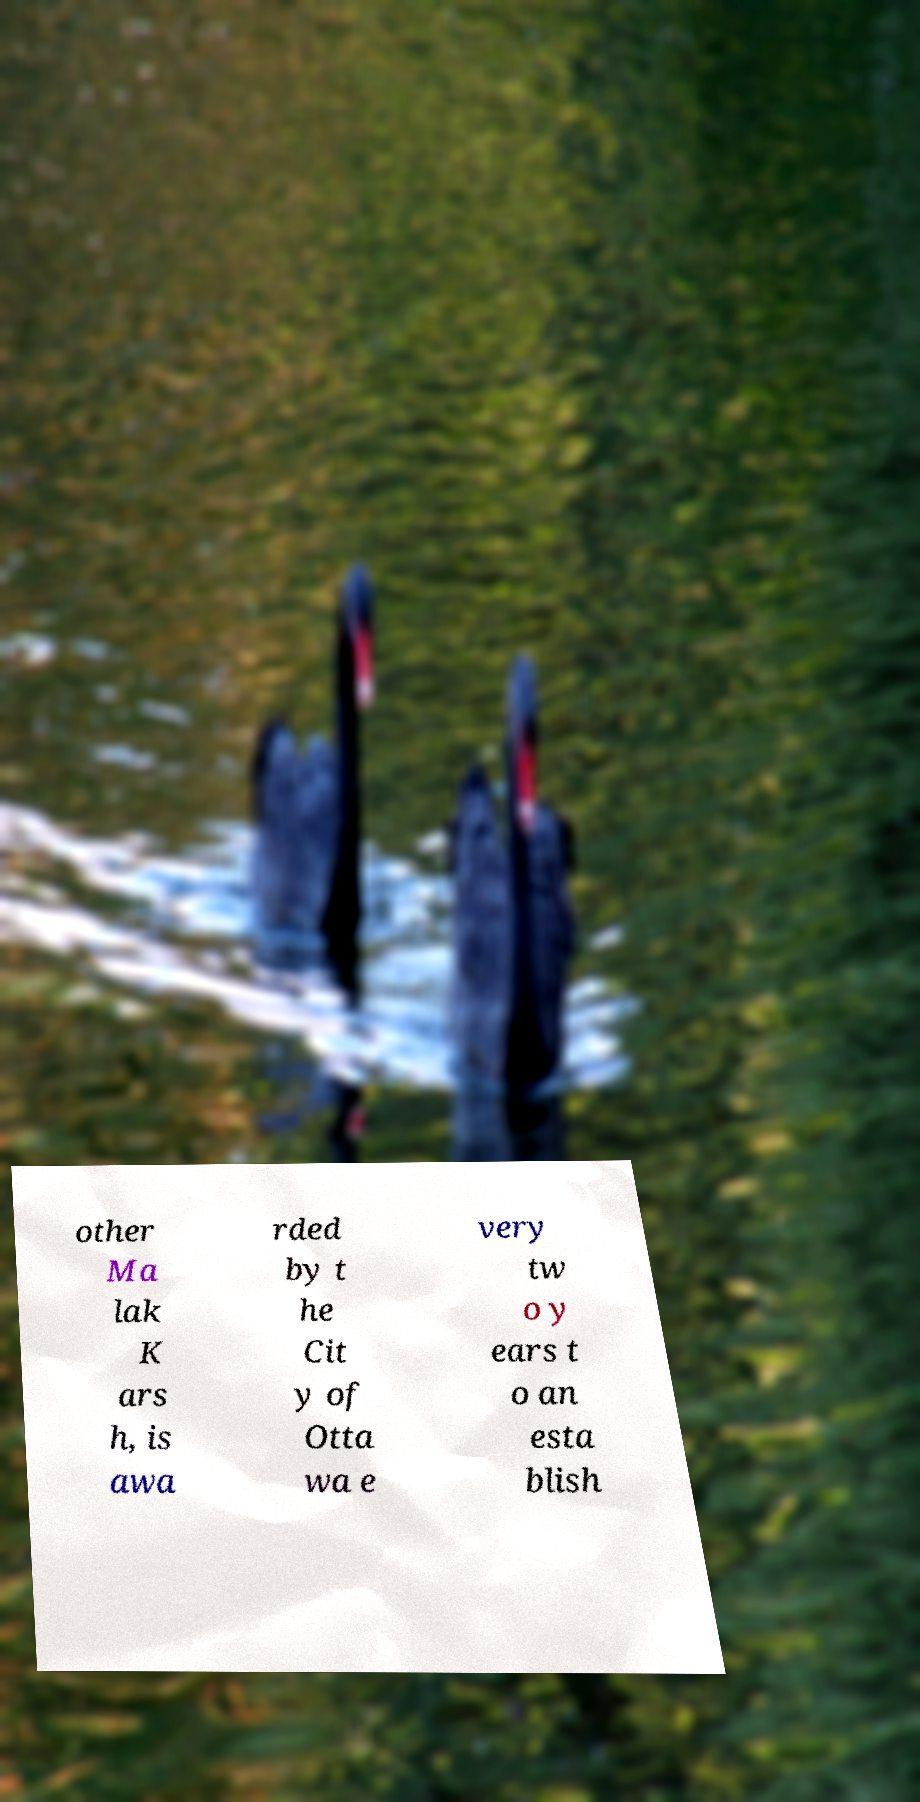For documentation purposes, I need the text within this image transcribed. Could you provide that? other Ma lak K ars h, is awa rded by t he Cit y of Otta wa e very tw o y ears t o an esta blish 